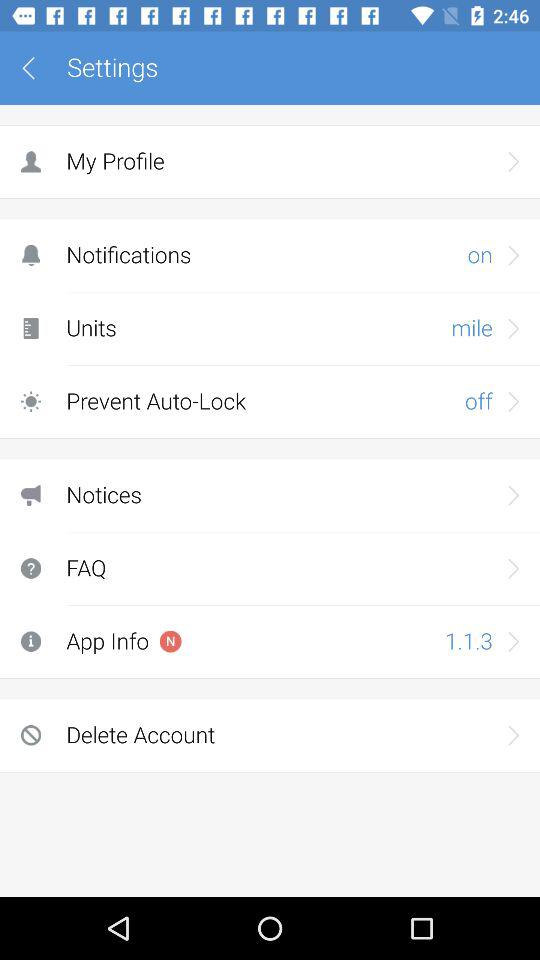What is the current status of the "Prevent Auto-Lock" setting? The current status of the "Prevent Auto-Lock" setting is "off". 